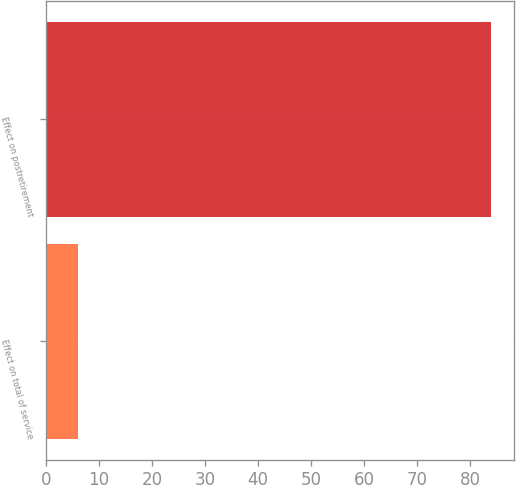<chart> <loc_0><loc_0><loc_500><loc_500><bar_chart><fcel>Effect on total of service<fcel>Effect on postretirement<nl><fcel>6<fcel>84<nl></chart> 